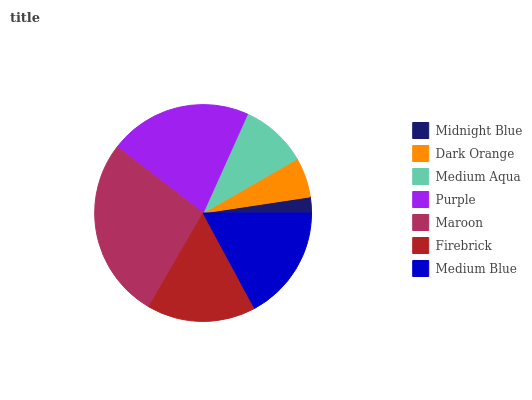Is Midnight Blue the minimum?
Answer yes or no. Yes. Is Maroon the maximum?
Answer yes or no. Yes. Is Dark Orange the minimum?
Answer yes or no. No. Is Dark Orange the maximum?
Answer yes or no. No. Is Dark Orange greater than Midnight Blue?
Answer yes or no. Yes. Is Midnight Blue less than Dark Orange?
Answer yes or no. Yes. Is Midnight Blue greater than Dark Orange?
Answer yes or no. No. Is Dark Orange less than Midnight Blue?
Answer yes or no. No. Is Firebrick the high median?
Answer yes or no. Yes. Is Firebrick the low median?
Answer yes or no. Yes. Is Dark Orange the high median?
Answer yes or no. No. Is Maroon the low median?
Answer yes or no. No. 